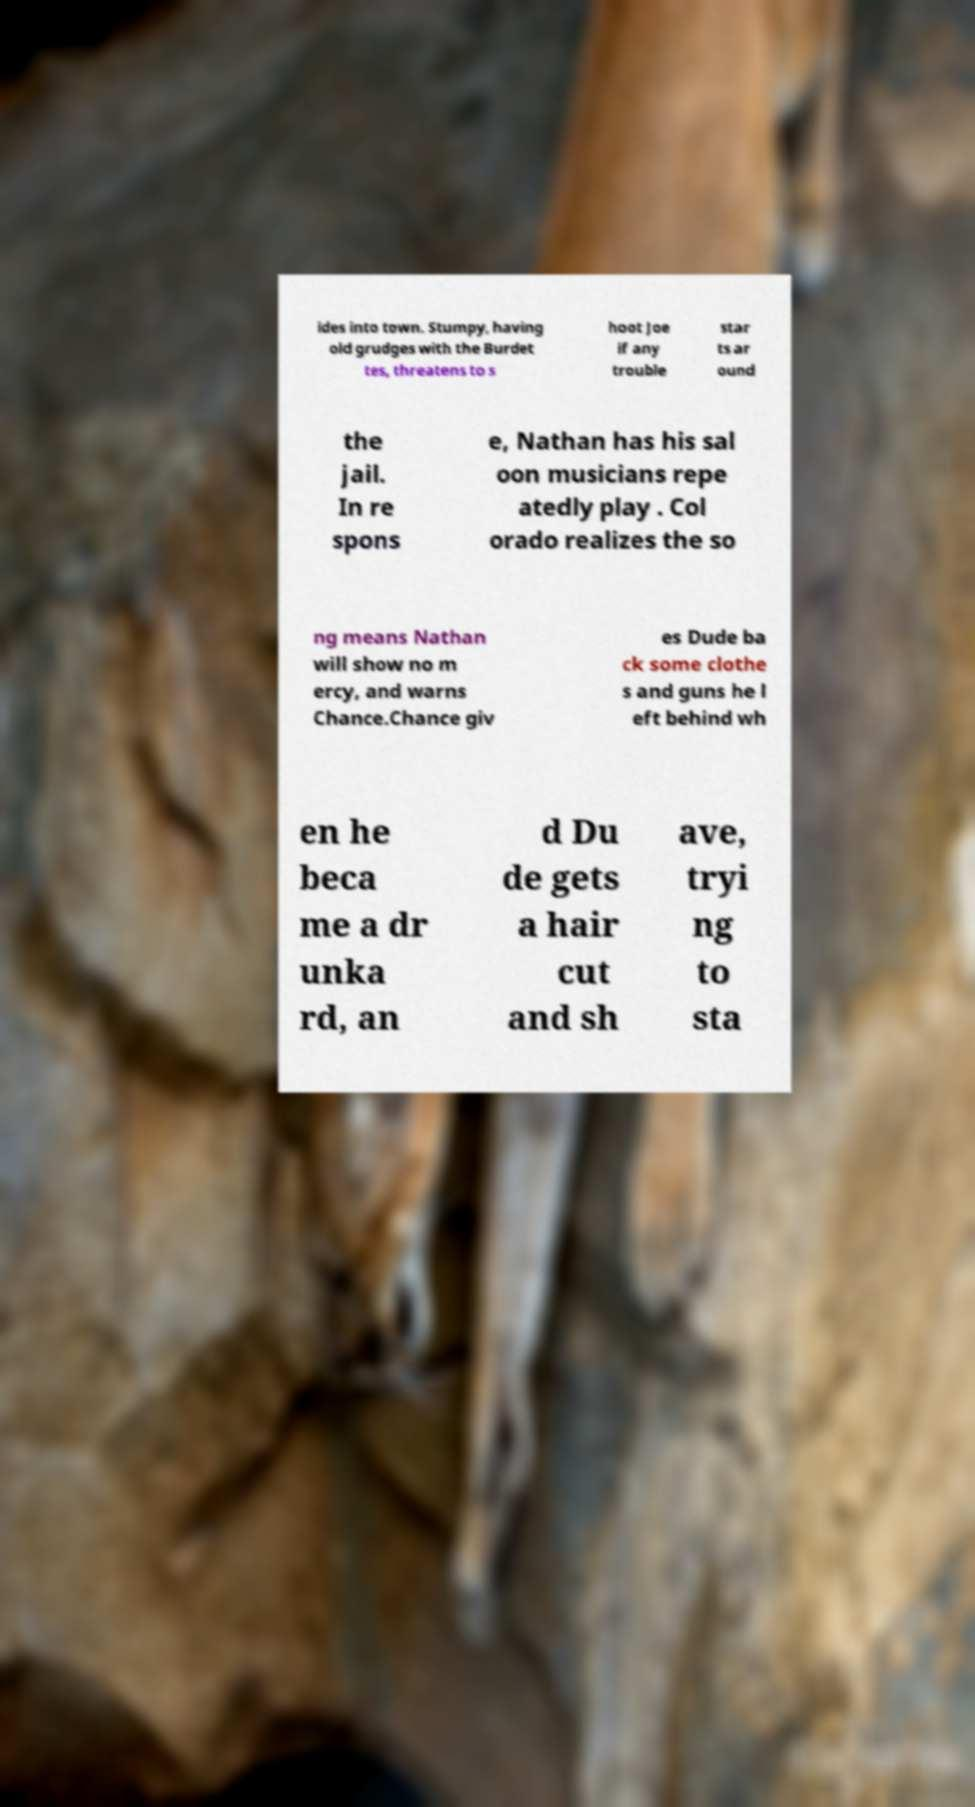Could you assist in decoding the text presented in this image and type it out clearly? ides into town. Stumpy, having old grudges with the Burdet tes, threatens to s hoot Joe if any trouble star ts ar ound the jail. In re spons e, Nathan has his sal oon musicians repe atedly play . Col orado realizes the so ng means Nathan will show no m ercy, and warns Chance.Chance giv es Dude ba ck some clothe s and guns he l eft behind wh en he beca me a dr unka rd, an d Du de gets a hair cut and sh ave, tryi ng to sta 